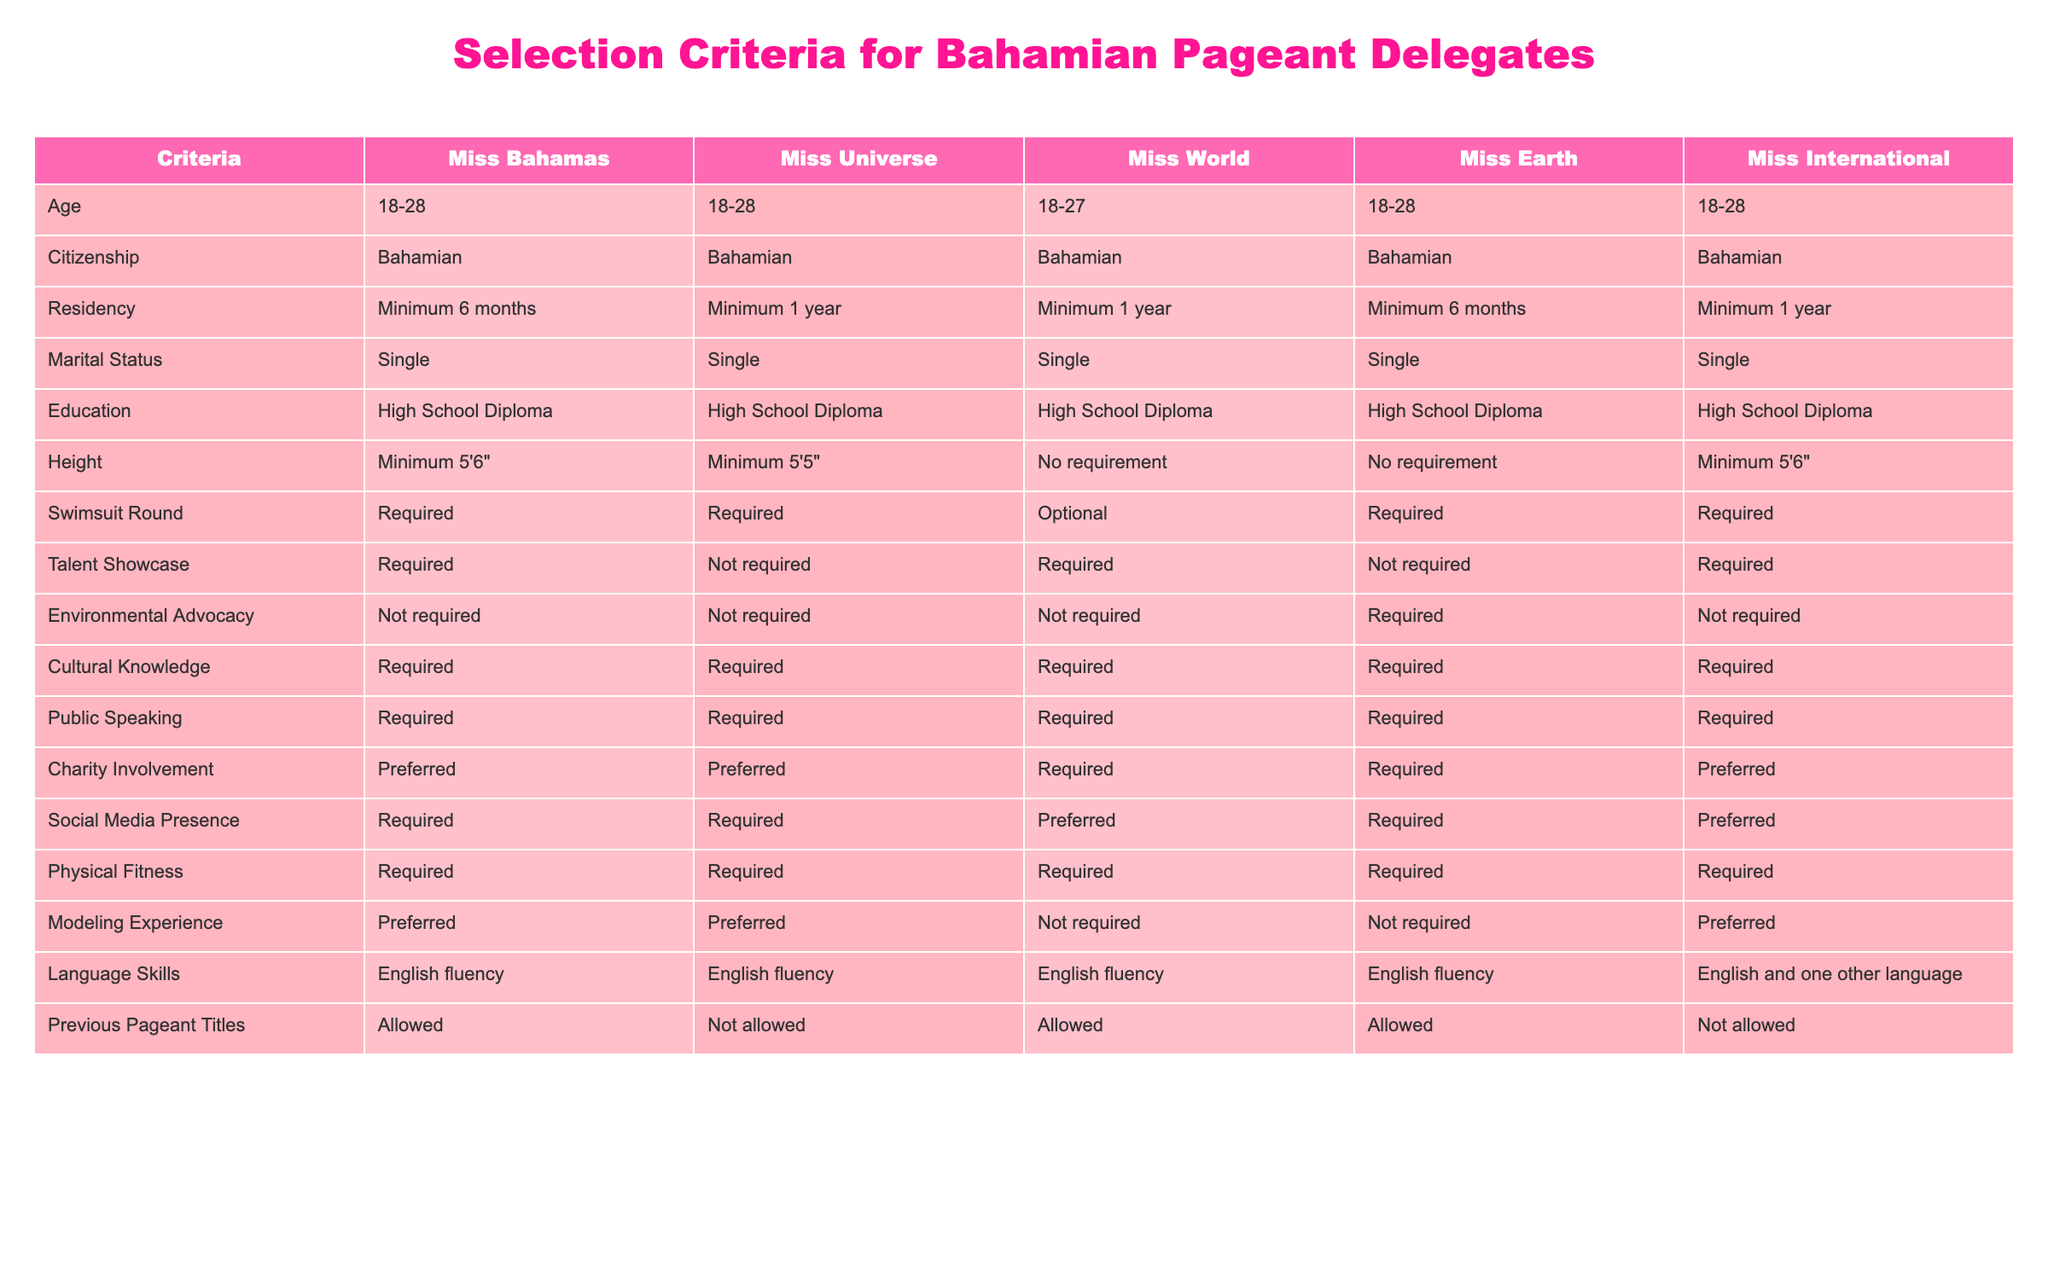What is the required age range for Miss Earth delegates? According to the table, the specified age range for Miss Earth delegates is 18-28.
Answer: 18-28 Is a high school diploma required for Miss Universe contestants? Yes, the table indicates that a high school diploma is required for Miss Universe contestants.
Answer: Yes How many pageants require modeling experience? Analyzing the table, Miss Bahamas, Miss International, and Miss Bahamas require modeling experience, totaling three pageants.
Answer: 3 Do all pageants have the same residency requirements? No, the table shows differing residency requirements: Miss Bahamas and Miss Earth require a minimum of six months, while Miss Universe, Miss World, and Miss International require a minimum of one year.
Answer: No Which pageant requires environmental advocacy? Only Miss Earth requires environmental advocacy according to the table, while the other pageants do not.
Answer: Miss Earth What pageants allow previous pageant titles? The table indicates that Miss Bahamas, Miss World, and Miss Earth allow previous pageant titles, while Miss Universe and Miss International do not.
Answer: Miss Bahamas, Miss World, Miss Earth How do the height requirements for Miss Universe and Miss International compare? The table specifies that Miss Universe has a minimum height requirement of 5'5", while Miss International has a minimum height requirement of 5'6". This shows Miss International has a stricter requirement.
Answer: Miss International is stricter Which two aspects are required for all pageants? By reviewing the table, it is clear that Physical Fitness and Cultural Knowledge are required for all pageants listed.
Answer: Physical Fitness and Cultural Knowledge What is the average height requirement across all pageants? There are three height requirements listed (5'5", 5'6", and 5'6"). Converting to inches, the average is calculated as (65 + 66 + 66) / 3 = 65.67, which does not round to a whole number. Thus the average height requirement is approximately 5'6".
Answer: Approximately 5'6" 